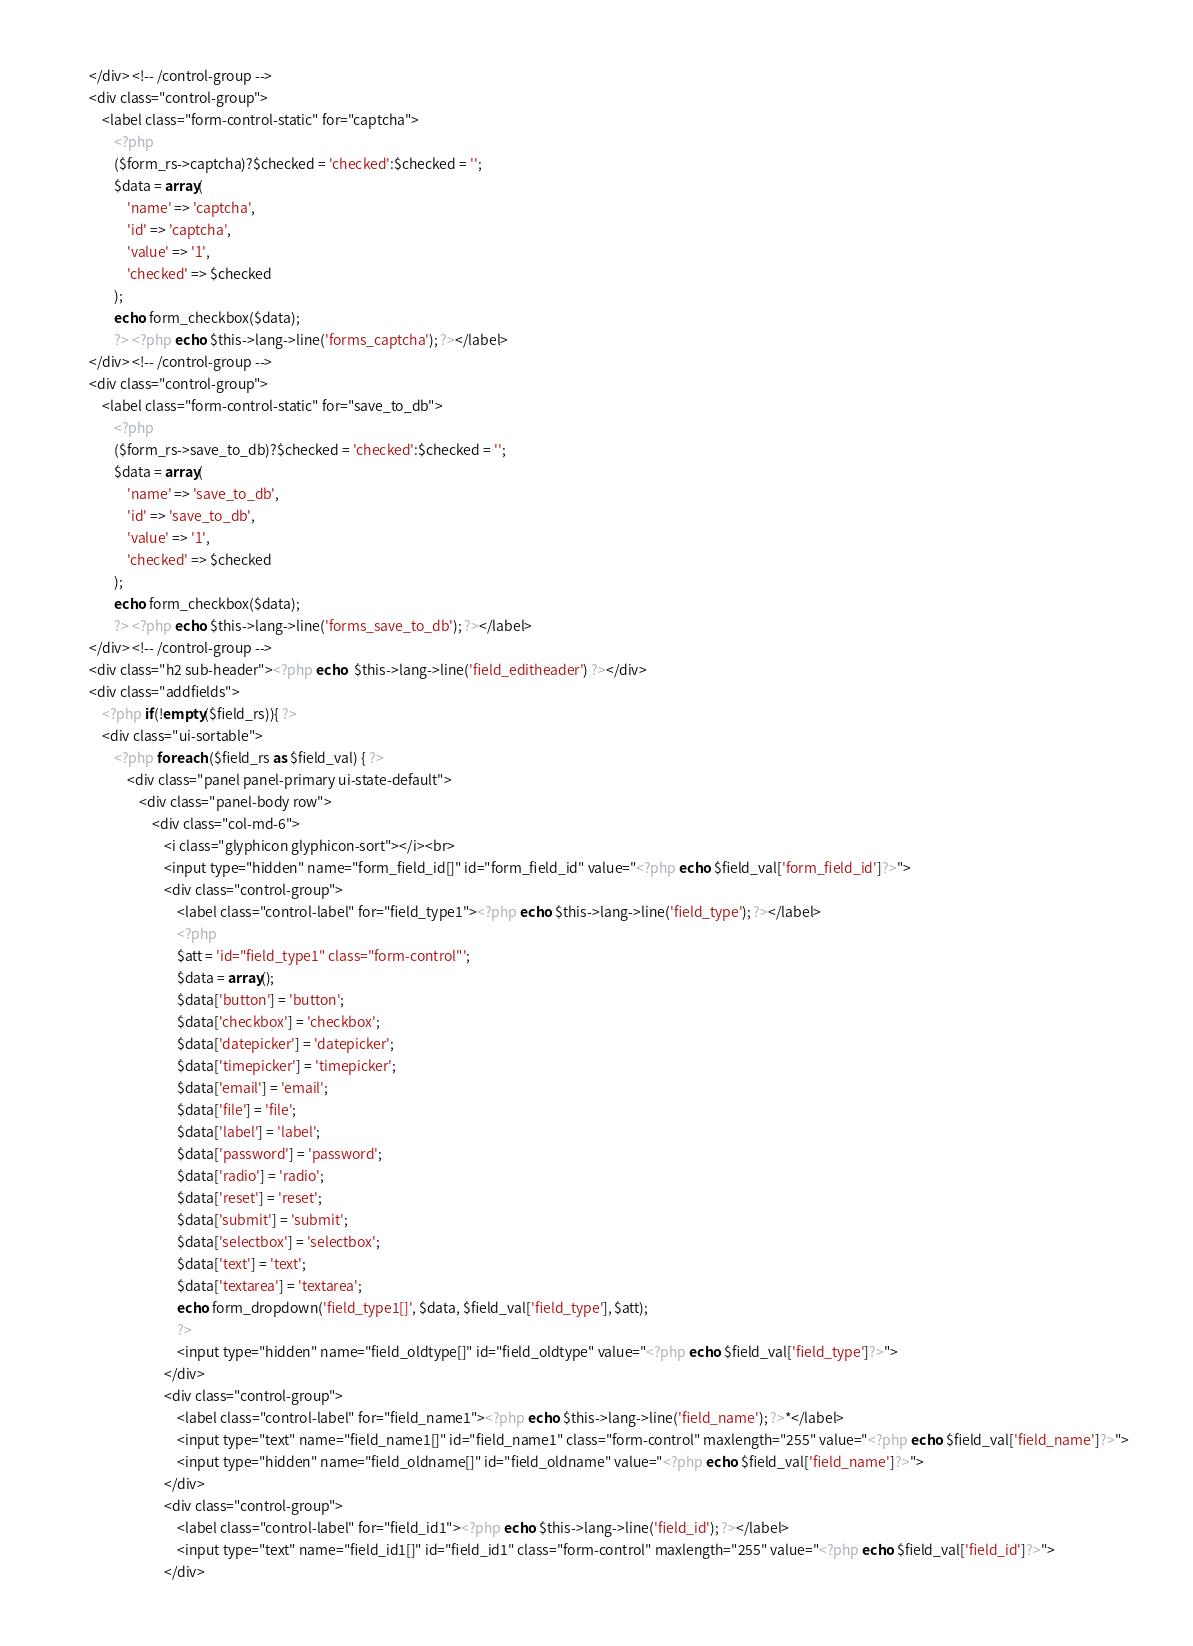<code> <loc_0><loc_0><loc_500><loc_500><_PHP_>        </div> <!-- /control-group -->
        <div class="control-group">										
            <label class="form-control-static" for="captcha">
                <?php
                ($form_rs->captcha)?$checked = 'checked':$checked = '';
                $data = array(
                    'name' => 'captcha',
                    'id' => 'captcha',
                    'value' => '1',
                    'checked' => $checked
                );
                echo form_checkbox($data);
                ?> <?php echo $this->lang->line('forms_captcha'); ?></label>	
        </div> <!-- /control-group -->
        <div class="control-group">										
            <label class="form-control-static" for="save_to_db">
                <?php
                ($form_rs->save_to_db)?$checked = 'checked':$checked = '';
                $data = array(
                    'name' => 'save_to_db',
                    'id' => 'save_to_db',
                    'value' => '1',
                    'checked' => $checked
                );
                echo form_checkbox($data);
                ?> <?php echo $this->lang->line('forms_save_to_db'); ?></label>	
        </div> <!-- /control-group -->
        <div class="h2 sub-header"><?php echo  $this->lang->line('field_editheader') ?></div>
        <div class="addfields">
            <?php if(!empty($field_rs)){ ?>
            <div class="ui-sortable">
                <?php foreach ($field_rs as $field_val) { ?>    
                    <div class="panel panel-primary ui-state-default">
                        <div class="panel-body row">
                            <div class="col-md-6">
                                <i class="glyphicon glyphicon-sort"></i><br>
                                <input type="hidden" name="form_field_id[]" id="form_field_id" value="<?php echo $field_val['form_field_id']?>">
                                <div class="control-group">
                                    <label class="control-label" for="field_type1"><?php echo $this->lang->line('field_type'); ?></label>
                                    <?php
                                    $att = 'id="field_type1" class="form-control"';
                                    $data = array();
                                    $data['button'] = 'button';
                                    $data['checkbox'] = 'checkbox';
                                    $data['datepicker'] = 'datepicker';
                                    $data['timepicker'] = 'timepicker';
                                    $data['email'] = 'email';
                                    $data['file'] = 'file';
                                    $data['label'] = 'label';
                                    $data['password'] = 'password';
                                    $data['radio'] = 'radio';
                                    $data['reset'] = 'reset';
                                    $data['submit'] = 'submit';
                                    $data['selectbox'] = 'selectbox';
                                    $data['text'] = 'text';
                                    $data['textarea'] = 'textarea';
                                    echo form_dropdown('field_type1[]', $data, $field_val['field_type'], $att);
                                    ?>
                                    <input type="hidden" name="field_oldtype[]" id="field_oldtype" value="<?php echo $field_val['field_type']?>">
                                </div>            
                                <div class="control-group">	
                                    <label class="control-label" for="field_name1"><?php echo $this->lang->line('field_name'); ?>*</label>
                                    <input type="text" name="field_name1[]" id="field_name1" class="form-control" maxlength="255" value="<?php echo $field_val['field_name']?>">
                                    <input type="hidden" name="field_oldname[]" id="field_oldname" value="<?php echo $field_val['field_name']?>">
                                </div>
                                <div class="control-group">	
                                    <label class="control-label" for="field_id1"><?php echo $this->lang->line('field_id'); ?></label>
                                    <input type="text" name="field_id1[]" id="field_id1" class="form-control" maxlength="255" value="<?php echo $field_val['field_id']?>">
                                </div></code> 